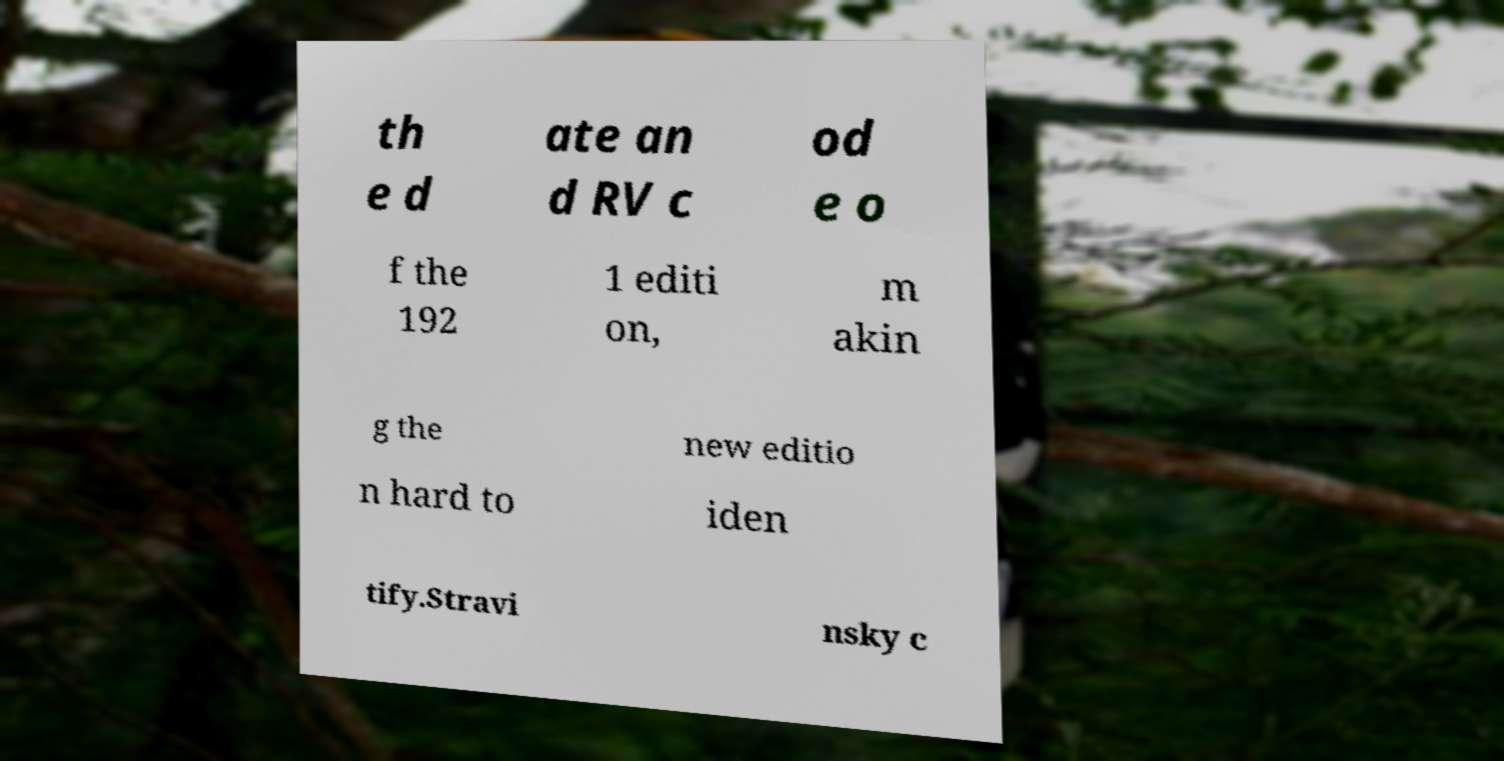What messages or text are displayed in this image? I need them in a readable, typed format. th e d ate an d RV c od e o f the 192 1 editi on, m akin g the new editio n hard to iden tify.Stravi nsky c 